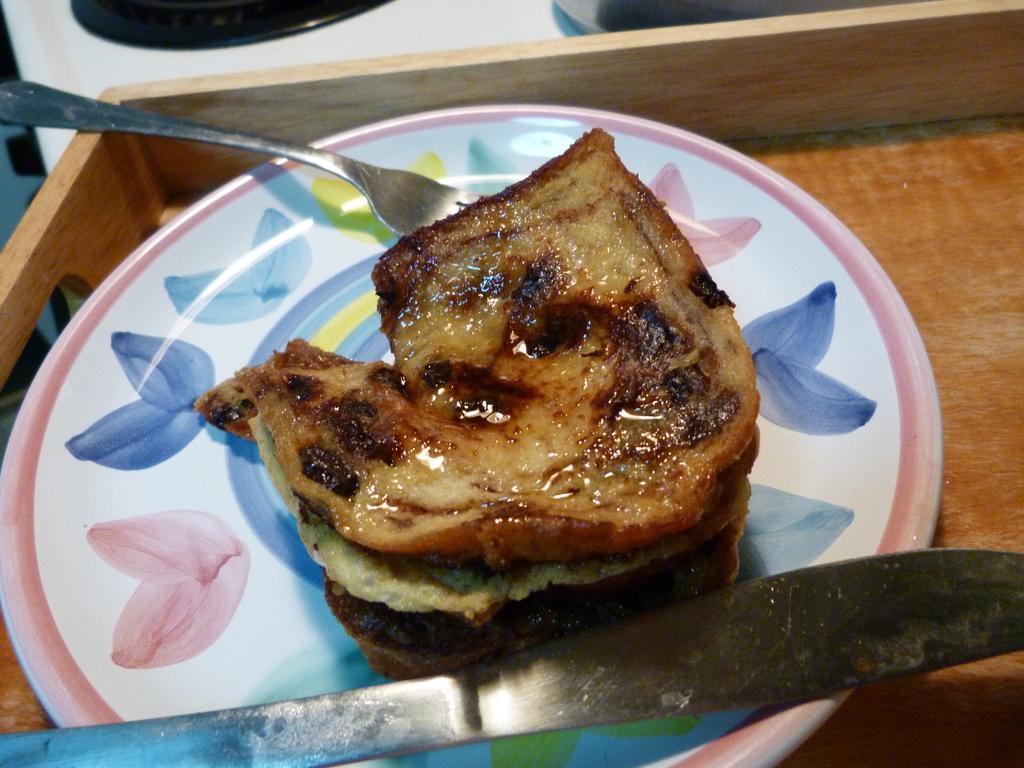Can you describe this image briefly? In this image there is a wooden tray having a plate. Plate is having some food, fork and a knife on it. Left top there is an object. 